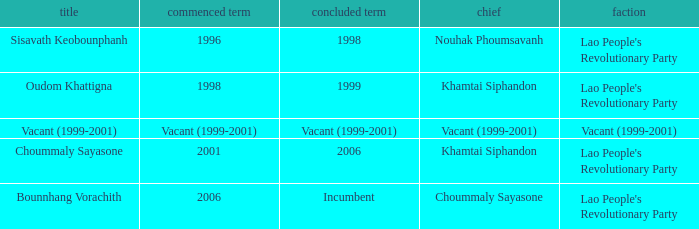What is Left Office, when Took Office is 1998? 1999.0. 